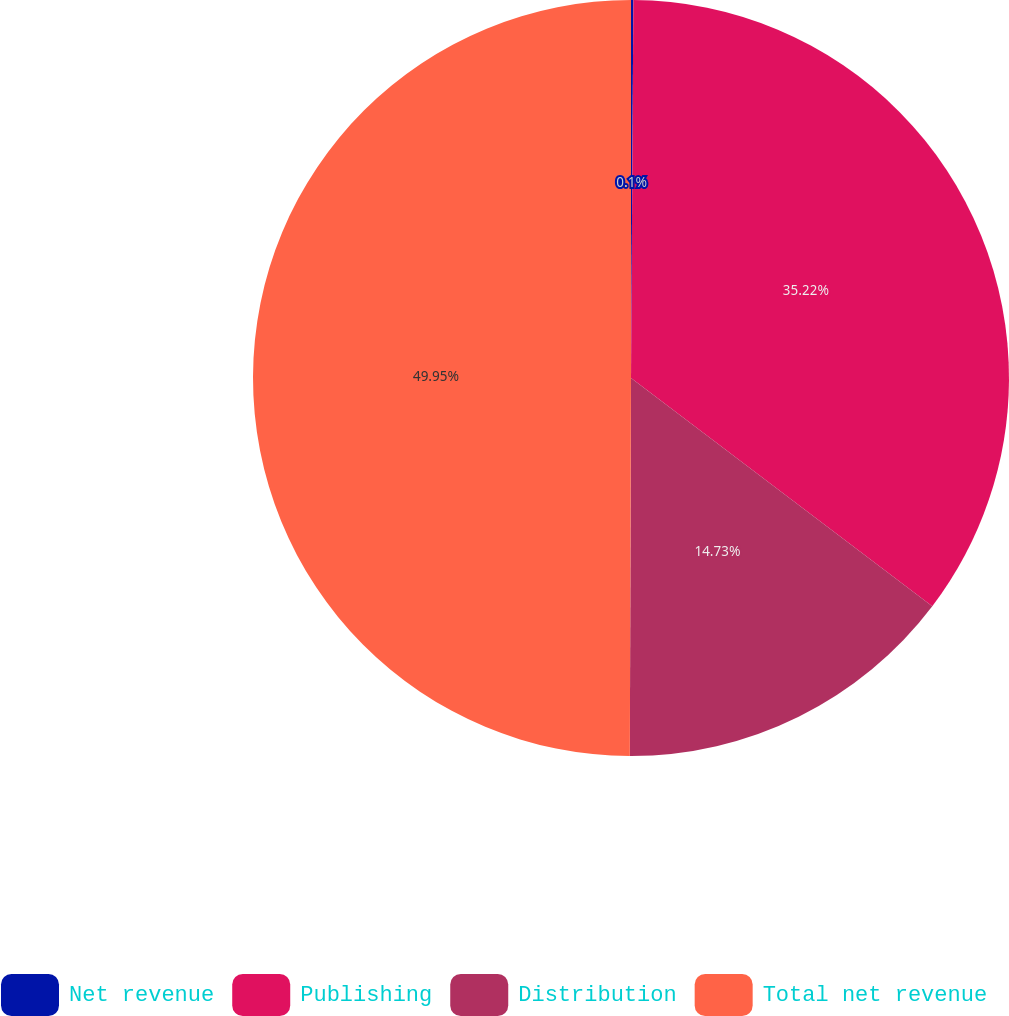Convert chart. <chart><loc_0><loc_0><loc_500><loc_500><pie_chart><fcel>Net revenue<fcel>Publishing<fcel>Distribution<fcel>Total net revenue<nl><fcel>0.1%<fcel>35.22%<fcel>14.73%<fcel>49.95%<nl></chart> 